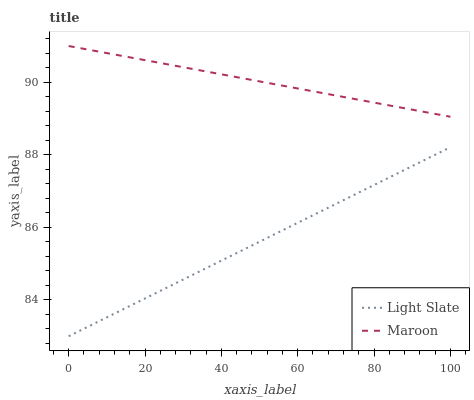Does Light Slate have the minimum area under the curve?
Answer yes or no. Yes. Does Maroon have the maximum area under the curve?
Answer yes or no. Yes. Does Maroon have the minimum area under the curve?
Answer yes or no. No. Is Maroon the smoothest?
Answer yes or no. Yes. Is Light Slate the roughest?
Answer yes or no. Yes. Is Maroon the roughest?
Answer yes or no. No. Does Light Slate have the lowest value?
Answer yes or no. Yes. Does Maroon have the lowest value?
Answer yes or no. No. Does Maroon have the highest value?
Answer yes or no. Yes. Is Light Slate less than Maroon?
Answer yes or no. Yes. Is Maroon greater than Light Slate?
Answer yes or no. Yes. Does Light Slate intersect Maroon?
Answer yes or no. No. 